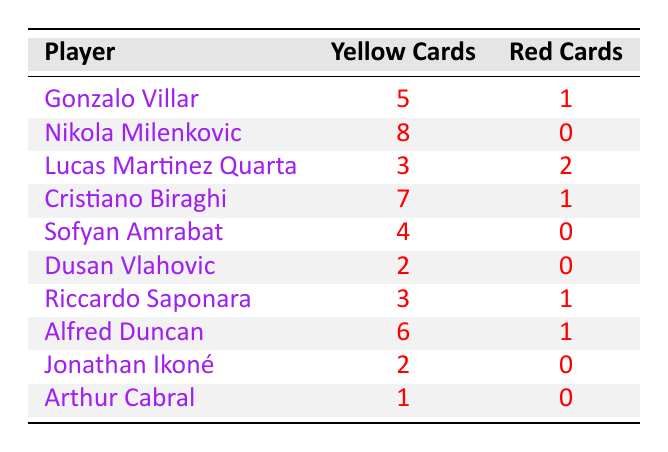What is the total number of yellow cards received by ACF Fiorentina players? To find the total yellow cards, I sum the yellow cards for each player: 5 + 8 + 3 + 7 + 4 + 2 + 3 + 6 + 2 + 1 = 41
Answer: 41 Who received the most yellow cards? Looking through the table, Nikola Milenkovic has 8 yellow cards, which is the highest number compared to other players.
Answer: Nikola Milenkovic How many players received red cards? By checking each player's red card count, I see that Gonzalo Villar, Cristiano Biraghi, Riccardo Saponara, Lucas Martinez Quarta, and Alfred Duncan each received red cards. That's a total of 4 unique players.
Answer: 4 What is the average number of yellow cards received per player? There are 10 players in total. The total yellow cards are 41. To find the average, I divide the total yellow cards by the total players: 41 / 10 = 4.1.
Answer: 4.1 Did any player receive 0 red cards? By reviewing the red card counts, I can confirm that Nikola Milenkovic, Sofyan Amrabat, Dusan Vlahovic, Jonathan Ikoné, and Arthur Cabral each received 0 red cards. Therefore, the answer is yes.
Answer: Yes What is the difference in the number of yellow cards between the player with the most and the player with the least? The player with the most yellow cards is Nikola Milenkovic with 8 yellow cards, and the player with the least is Arthur Cabral with 1 yellow card. The difference is 8 - 1 = 7.
Answer: 7 Which player received the same number of red cards as yellow cards? Checking the table, I find that Lucas Martinez Quarta received 3 yellow cards and 2 red cards, while no player has an equal count in both categories. The answer is none.
Answer: None What percentage of players received 1 or more red cards? There are 4 players who received red cards out of 10 players. To find the percentage, I calculate (4 / 10) * 100 = 40%.
Answer: 40% How many yellow cards did Dusan Vlahovic receive? Referring to the table, I see that Dusan Vlahovic has 2 yellow cards indicated next to his name.
Answer: 2 How many players received more yellow cards than red cards? Evaluating the table, I find that all except for Lucas Martinez Quarta (3 yellow, 2 red) received more yellow cards than red cards, making it a total of 9 players.
Answer: 9 